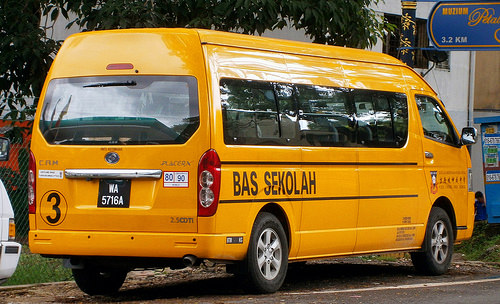<image>
Is there a car behind the van? Yes. From this viewpoint, the car is positioned behind the van, with the van partially or fully occluding the car. 